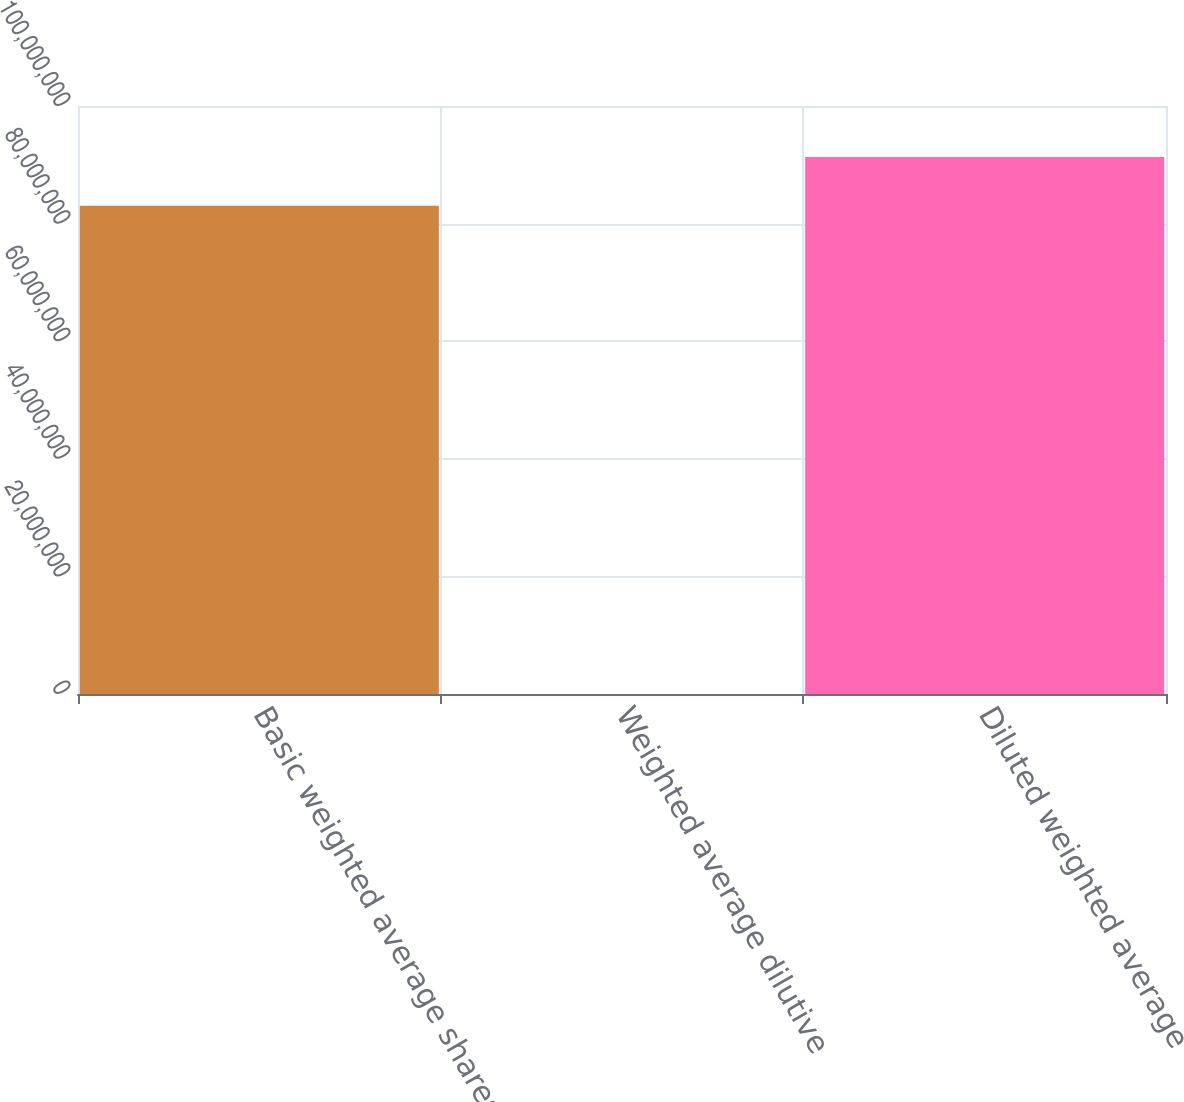Convert chart to OTSL. <chart><loc_0><loc_0><loc_500><loc_500><bar_chart><fcel>Basic weighted average shares<fcel>Weighted average dilutive<fcel>Diluted weighted average<nl><fcel>8.30336e+07<fcel>3.12<fcel>9.13369e+07<nl></chart> 